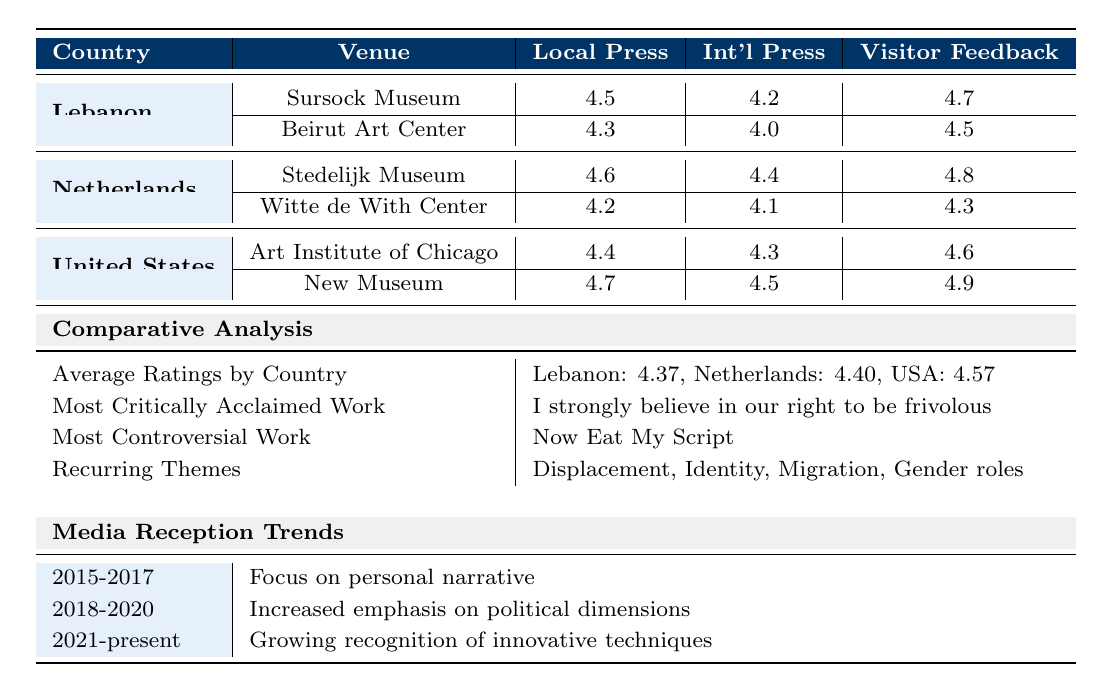What is the local press rating for the New Museum in New York? The table shows that the New Museum has a local press rating of 4.7.
Answer: 4.7 Which country had the highest average rating among the three countries listed? The average ratings for each country are Lebanon (4.37), Netherlands (4.40), and the United States (4.57). The United States has the highest average rating.
Answer: United States What is the visitor feedback rating for the Stedelijk Museum? According to the table, the visitor feedback rating for the Stedelijk Museum is 4.8.
Answer: 4.8 Did the Witte de With Center have a higher local press rating than the Sursock Museum? The local press rating for the Witte de With Center is 4.2 and for the Sursock Museum is 4.5. Since 4.2 is less than 4.5, the statement is false.
Answer: No What is the most critically acclaimed work according to the comparative analysis in the table? The table indicates that the most critically acclaimed work is "I strongly believe in our right to be frivolous."
Answer: "I strongly believe in our right to be frivolous" Combine the local press ratings of the two venues in Lebanon and compare them to the average rating of the Netherlands. Local press ratings for Lebanon are 4.5 (Sursock Museum) + 4.3 (Beirut Art Center) = 8.8. The average local press rating for the Netherlands is (4.6 + 4.2) / 2 = 4.4. Comparing, 8.8 is greater than 4.4.
Answer: Greater What recurring themes are identified in the critical reception of Mounira Al Solh's works? The table lists themes such as Displacement, Identity, Migration, Gender roles, and Political commentary as the recurring themes.
Answer: Displacement, Identity, Migration, Gender roles, Political commentary Which venue received the highest visitor feedback and what was that score? The New Museum received the highest visitor feedback rating of 4.9.
Answer: New Museum, 4.9 Did the Stedelijk Museum have a lower international press rating than the Witte de With Center? The table shows Stedelijk Museum has an international press rating of 4.4, while the Witte de With Center has a rating of 4.1. Thus, the statement is false because 4.4 is greater than 4.1.
Answer: No What is the trend in media reception from 2018 to 2020? The table specifies that from 2018 to 2020, the trend showed an increased emphasis on political dimensions.
Answer: Increased emphasis on political dimensions What is the average visitor feedback for the venues in the United States? The visitor feedback ratings for the US venues are 4.6 (Art Institute of Chicago) and 4.9 (New Museum). The average is (4.6 + 4.9) / 2 = 4.75.
Answer: 4.75 